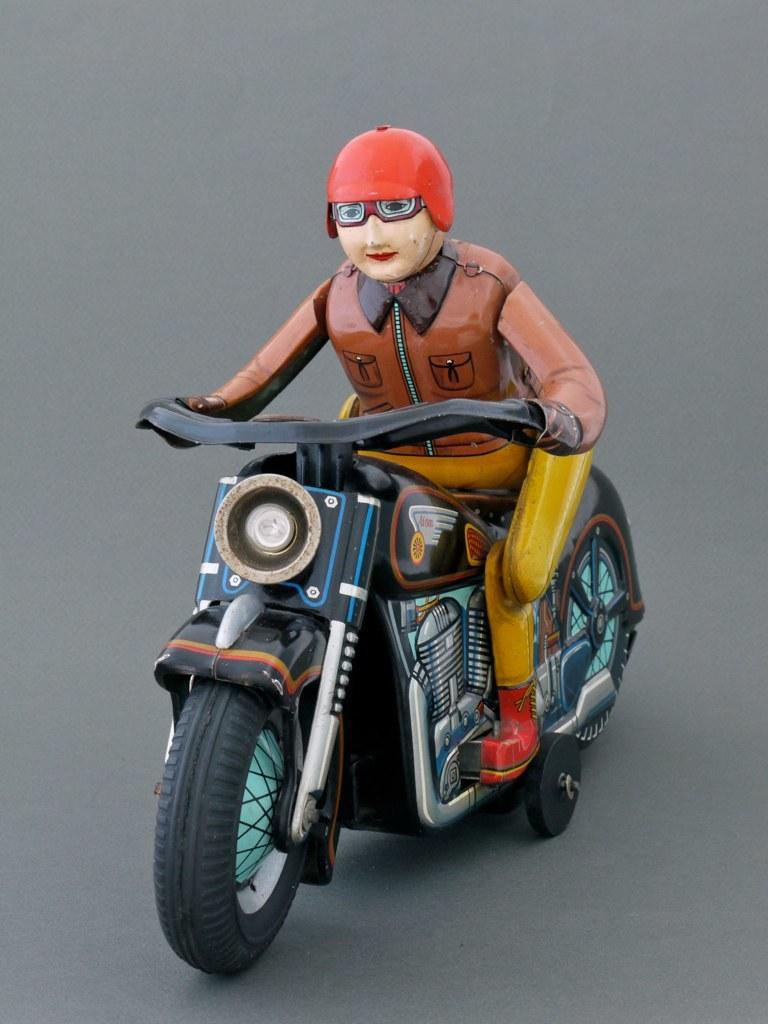What is the main subject in the center of the image? There is a toy in the center of the image. What is the person in the toy doing? A person is sitting on a bike in the toy. What color is the bottom part of the image? The bottom part of the image is grey. What type of skate is the person wearing in the image? There is no person wearing a skate in the image; the person is sitting on a bike within the toy. 